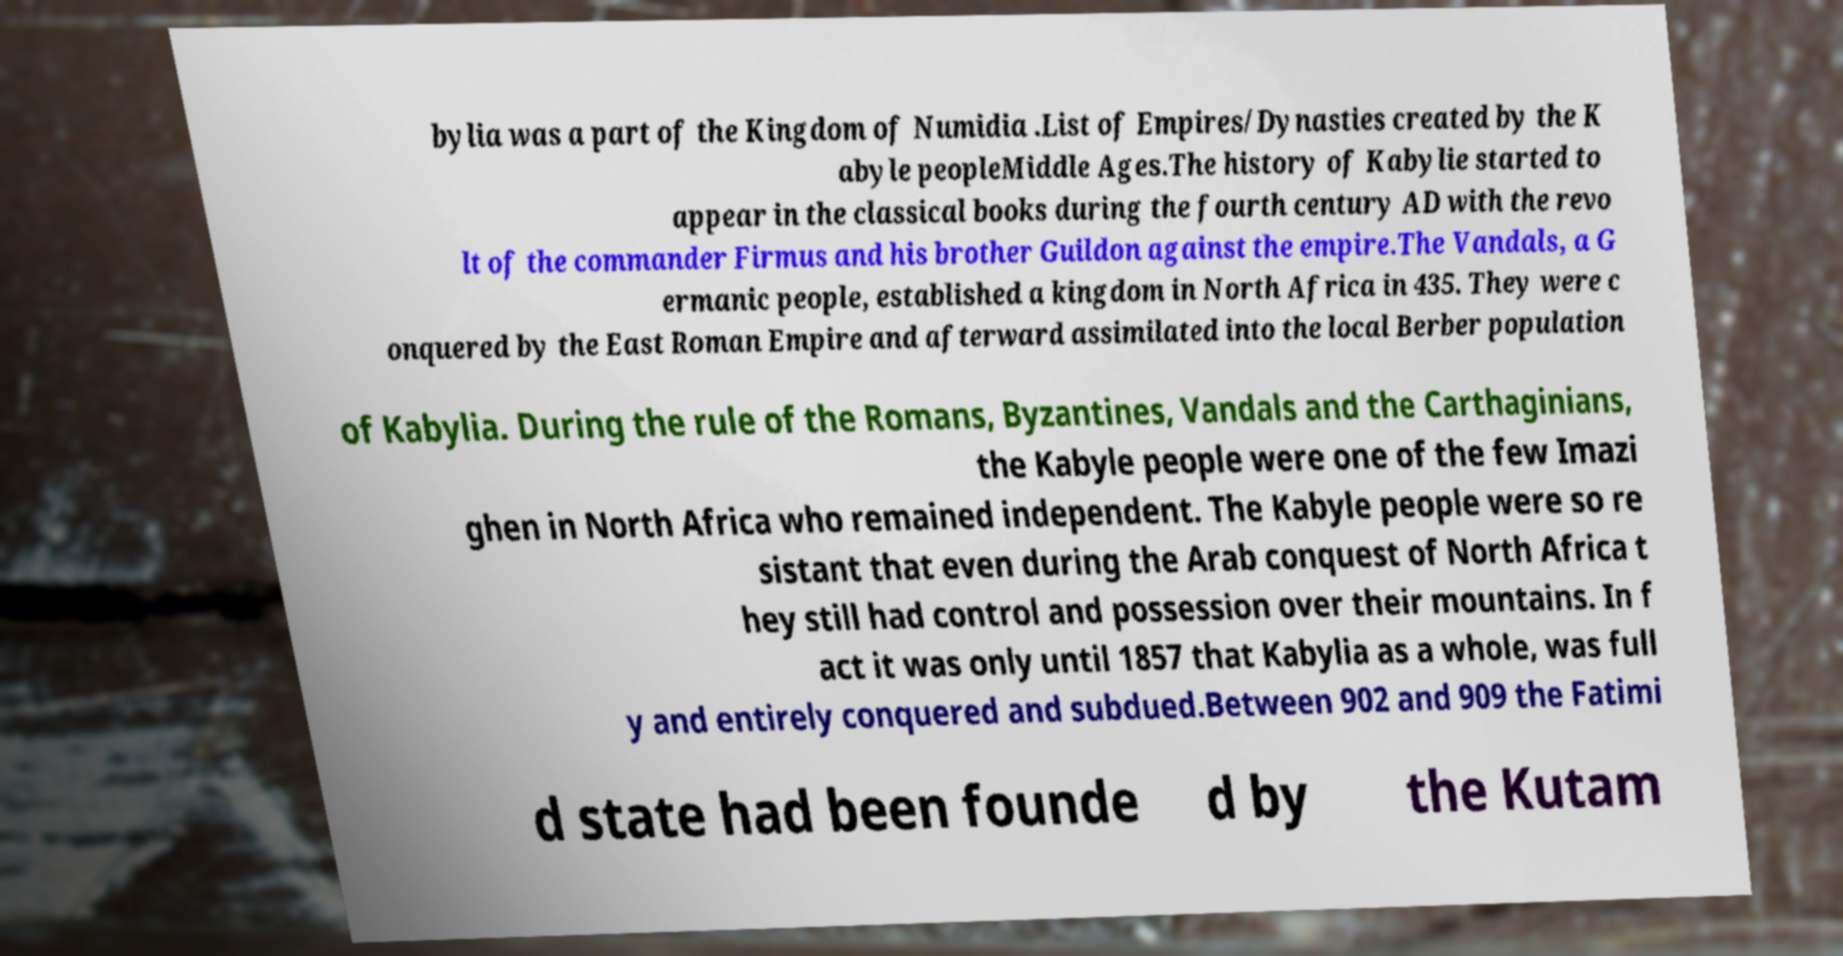Can you read and provide the text displayed in the image?This photo seems to have some interesting text. Can you extract and type it out for me? bylia was a part of the Kingdom of Numidia .List of Empires/Dynasties created by the K abyle peopleMiddle Ages.The history of Kabylie started to appear in the classical books during the fourth century AD with the revo lt of the commander Firmus and his brother Guildon against the empire.The Vandals, a G ermanic people, established a kingdom in North Africa in 435. They were c onquered by the East Roman Empire and afterward assimilated into the local Berber population of Kabylia. During the rule of the Romans, Byzantines, Vandals and the Carthaginians, the Kabyle people were one of the few Imazi ghen in North Africa who remained independent. The Kabyle people were so re sistant that even during the Arab conquest of North Africa t hey still had control and possession over their mountains. In f act it was only until 1857 that Kabylia as a whole, was full y and entirely conquered and subdued.Between 902 and 909 the Fatimi d state had been founde d by the Kutam 